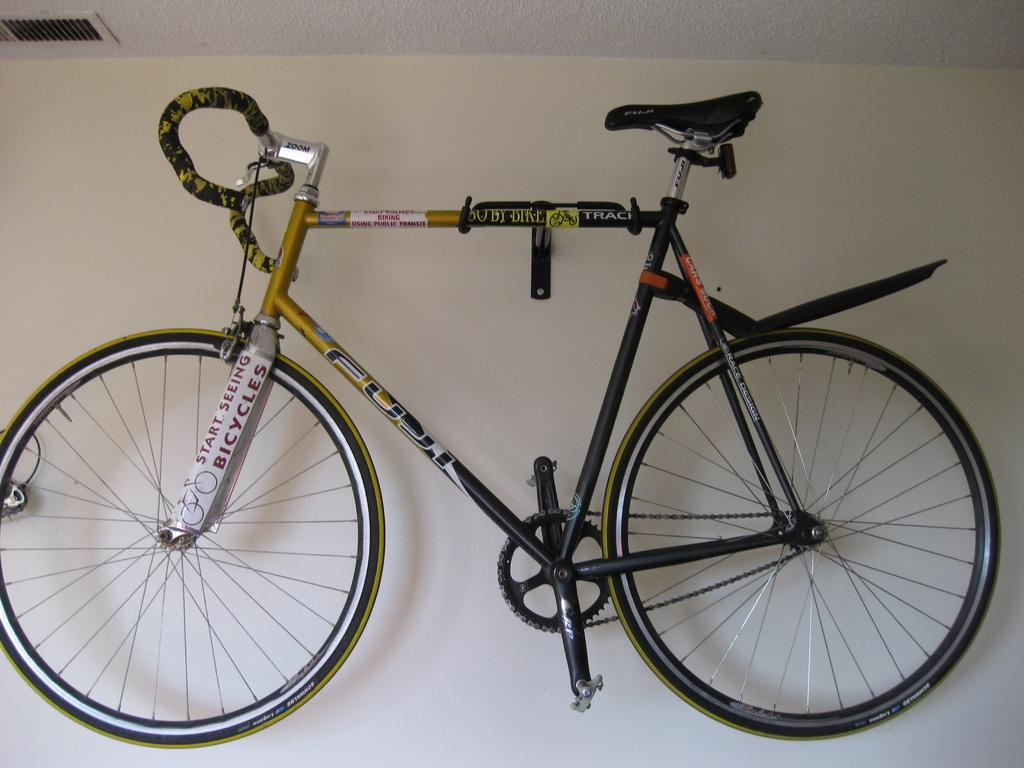What is the main object in the image? There is a bicycle in the image. Where is the bicycle located? The bicycle is hanging on the wall. What hobbies can be seen being practiced in the wilderness in the image? There is no reference to hobbies or wilderness in the image; it only features a bicycle hanging on the wall. 